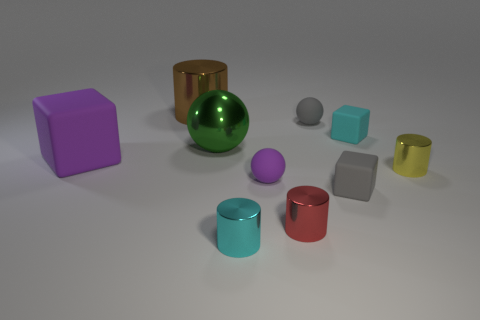Subtract 1 cylinders. How many cylinders are left? 3 Subtract all cylinders. How many objects are left? 6 Add 6 yellow metal cylinders. How many yellow metal cylinders exist? 7 Subtract 1 cyan cylinders. How many objects are left? 9 Subtract all big brown matte spheres. Subtract all tiny purple things. How many objects are left? 9 Add 8 green spheres. How many green spheres are left? 9 